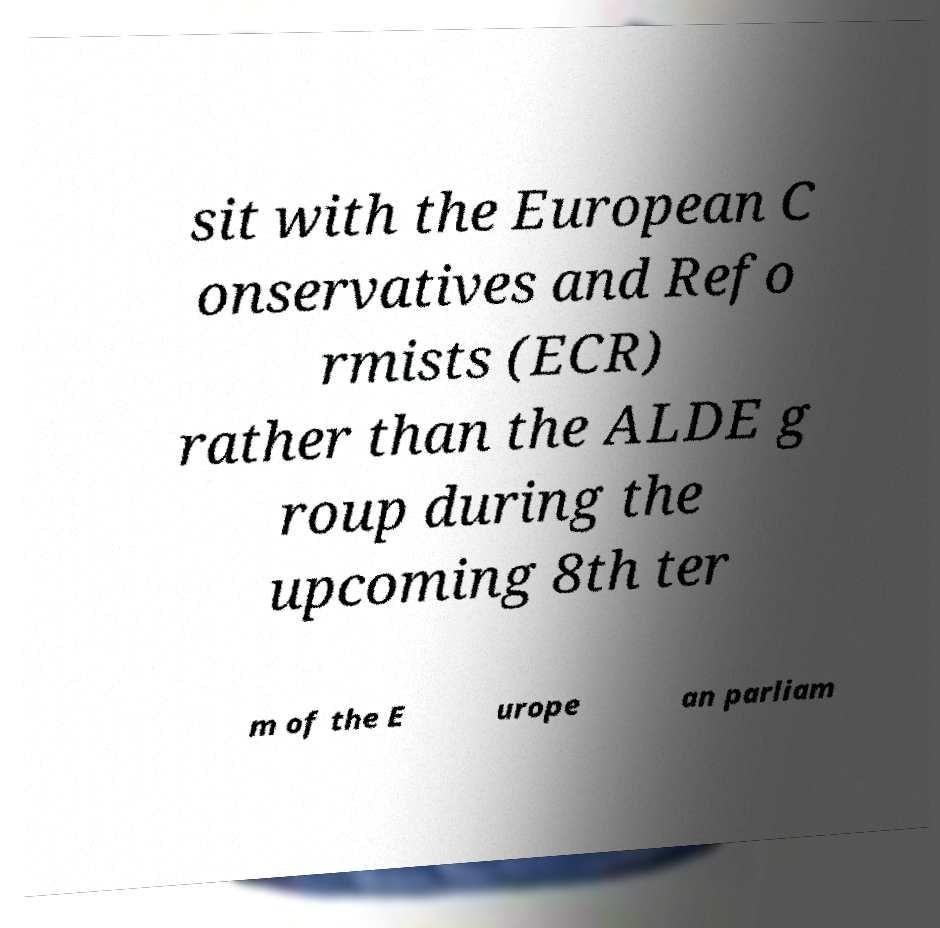Could you extract and type out the text from this image? sit with the European C onservatives and Refo rmists (ECR) rather than the ALDE g roup during the upcoming 8th ter m of the E urope an parliam 